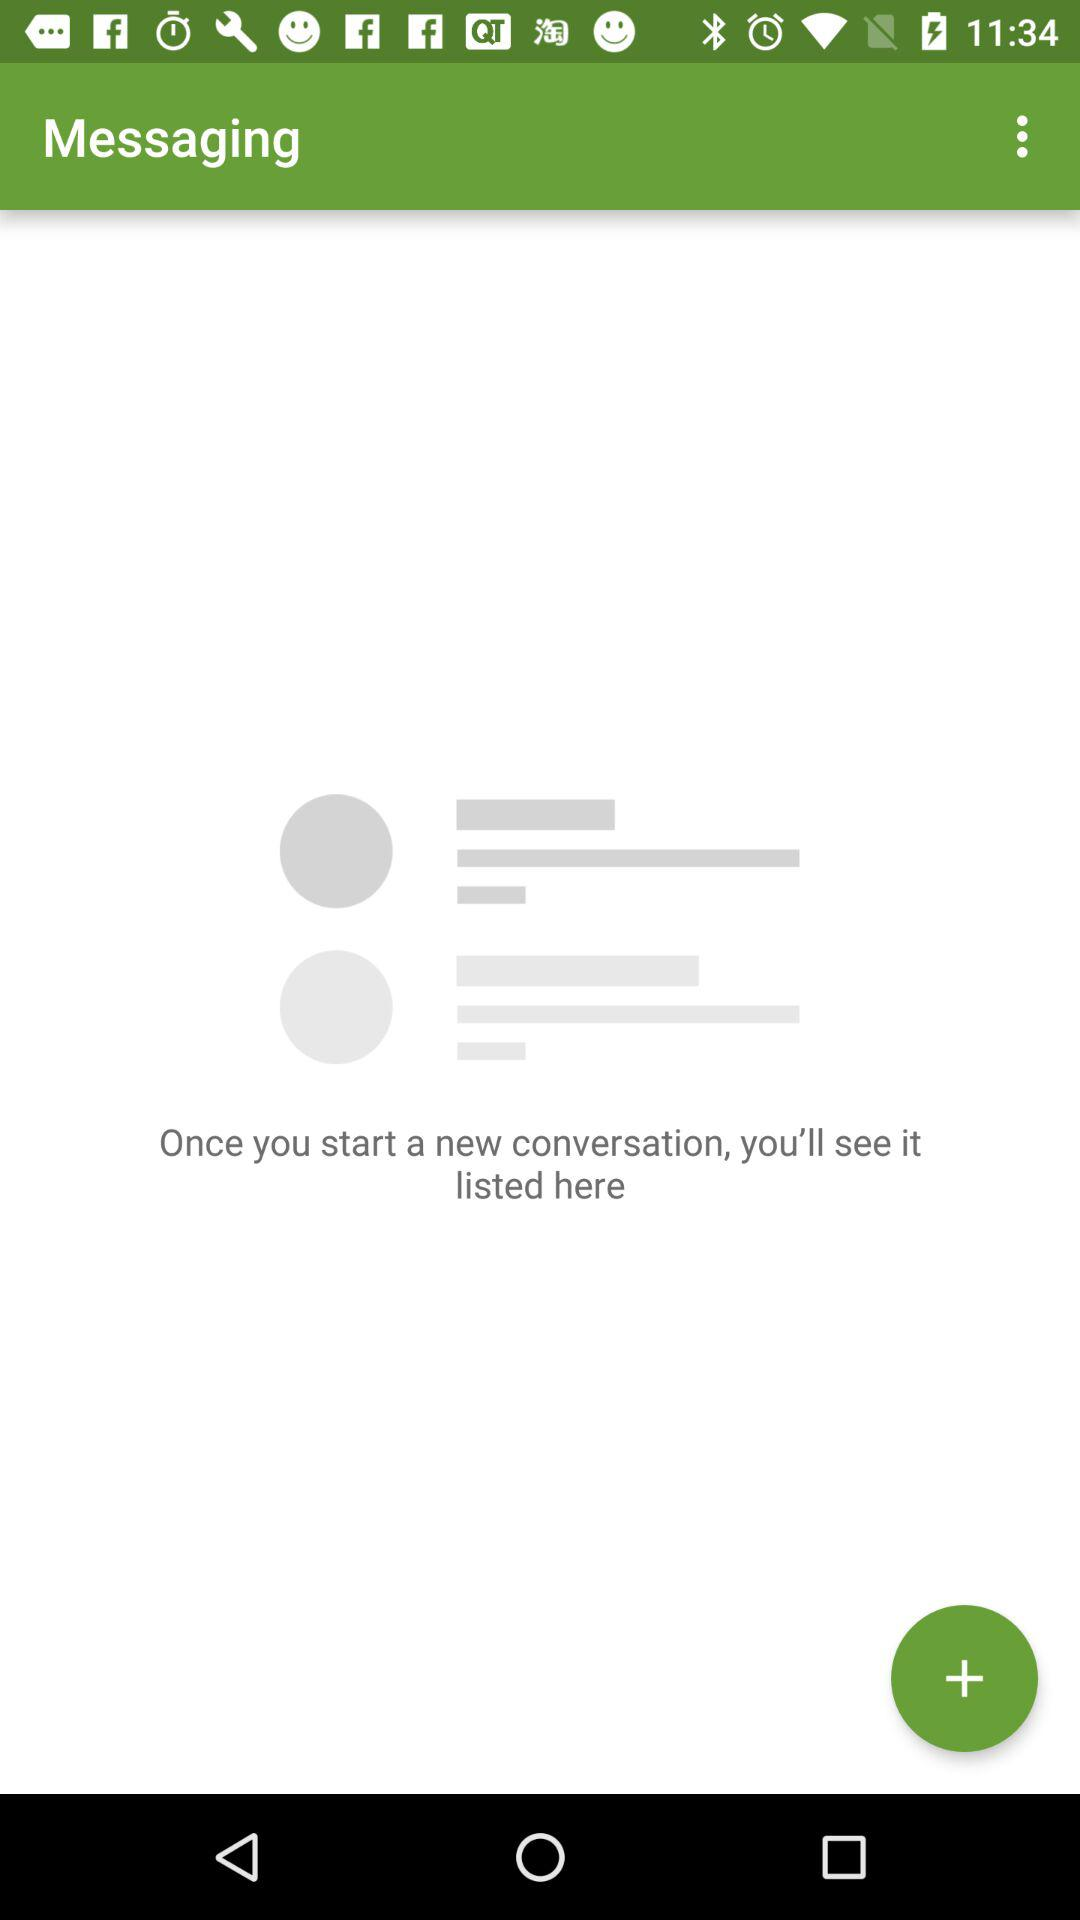What is the application name? The application name is "Messaging". 